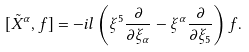Convert formula to latex. <formula><loc_0><loc_0><loc_500><loc_500>[ \tilde { X } ^ { \alpha } , f ] = - i l \left ( \xi ^ { 5 } \frac { \partial } { \partial \xi _ { \alpha } } - \xi ^ { \alpha } \frac { \partial } { \partial \xi _ { 5 } } \right ) f .</formula> 